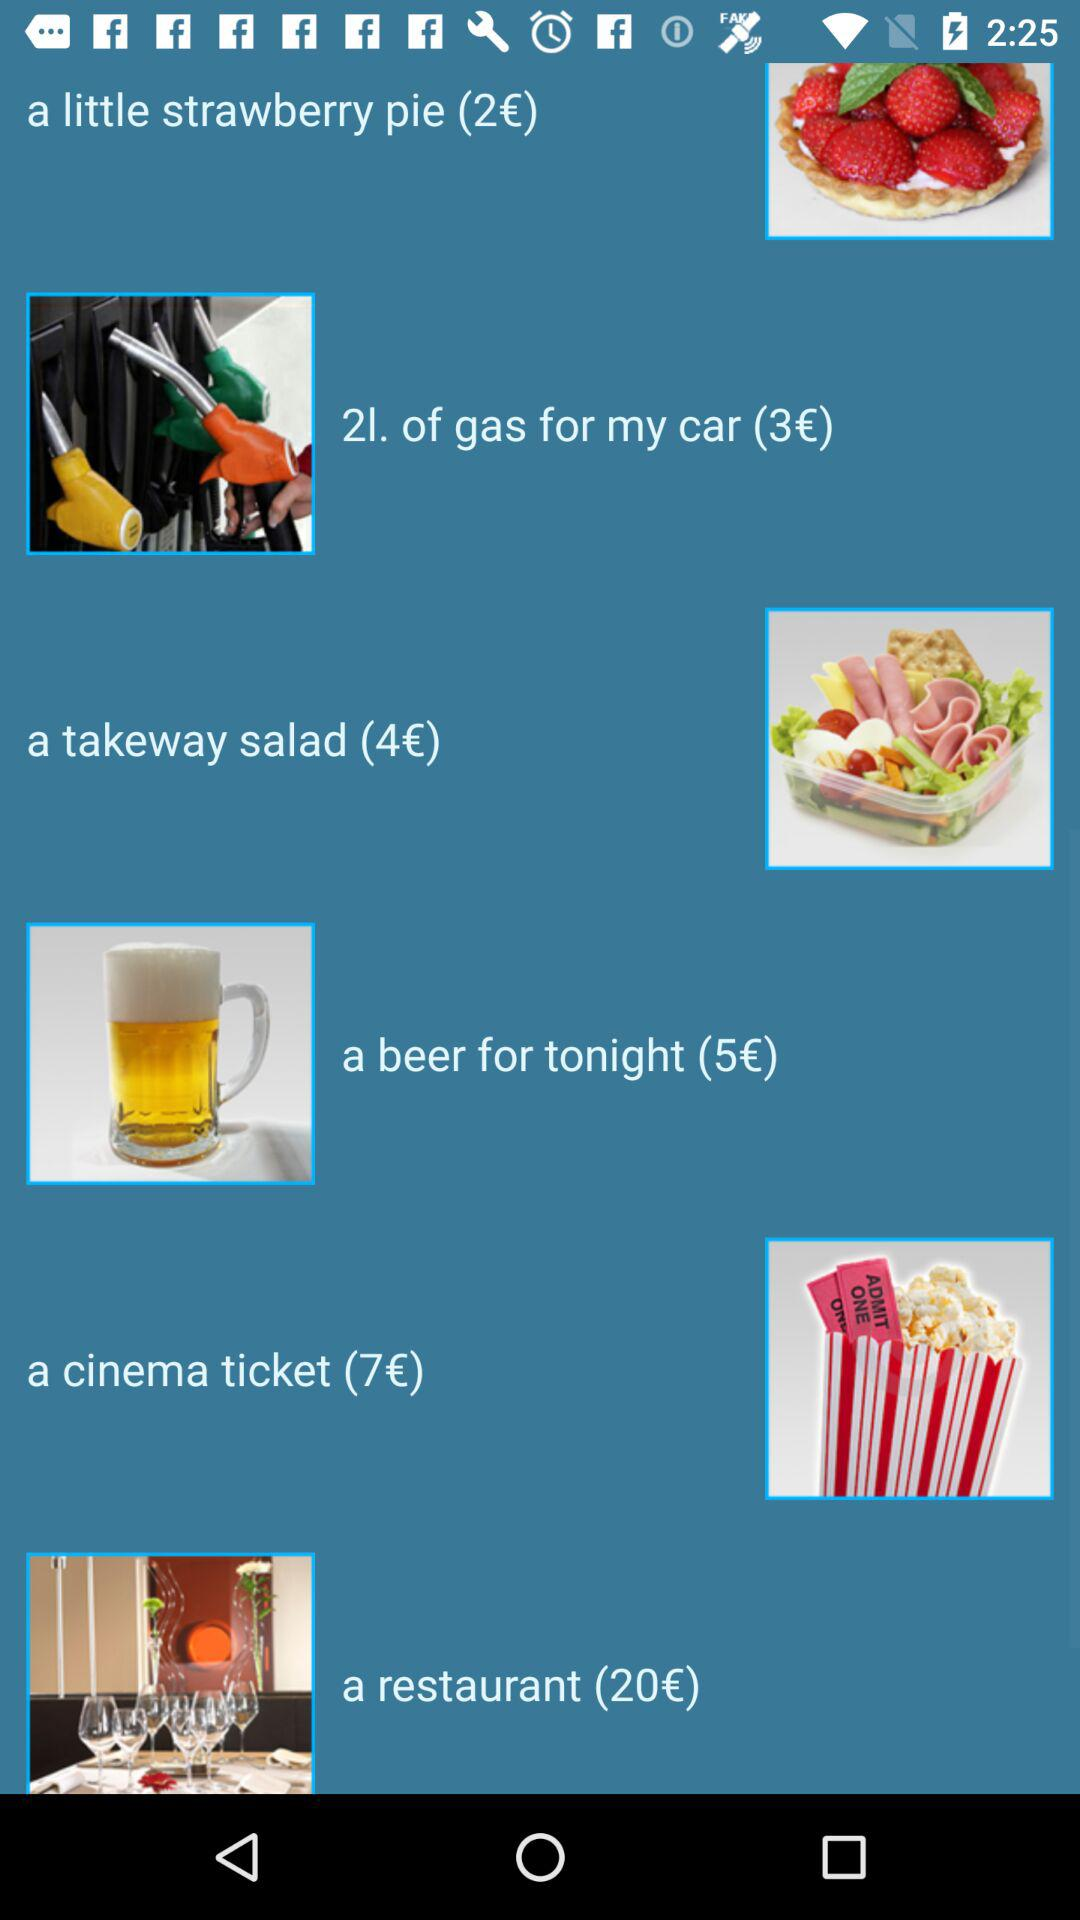What is the cost of the little strawberry pie? The cost of the little strawberry pie is 2 euros. 